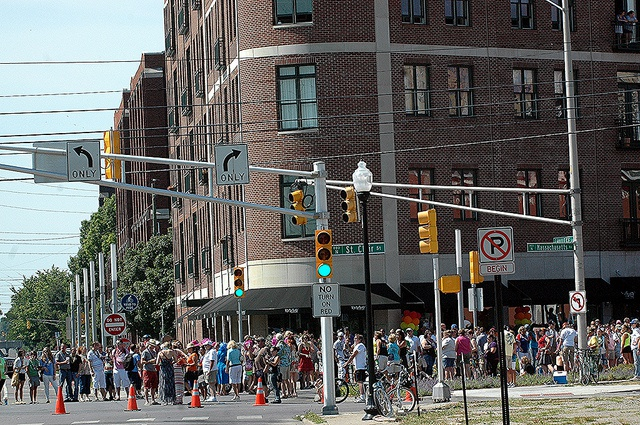Describe the objects in this image and their specific colors. I can see people in lightblue, black, gray, darkgray, and lightgray tones, traffic light in lightblue, black, gray, brown, and cyan tones, bicycle in lightblue, gray, darkgray, black, and lightgray tones, traffic light in lightblue, olive, gray, khaki, and orange tones, and people in lightblue, gray, black, and darkgray tones in this image. 